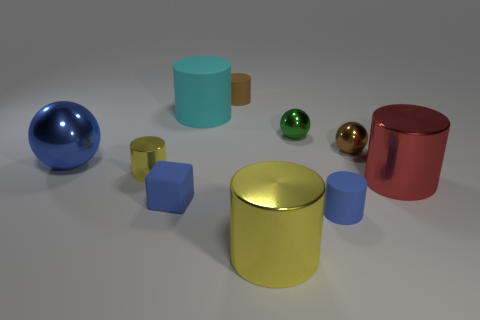Is there any other thing that is the same material as the cyan thing?
Keep it short and to the point. Yes. What number of objects are blue things on the right side of the small yellow metal cylinder or big cyan rubber objects?
Provide a succinct answer. 3. There is a rubber cylinder that is in front of the big blue shiny sphere; how big is it?
Provide a short and direct response. Small. What is the material of the large red cylinder?
Give a very brief answer. Metal. The metal object behind the tiny metal ball that is in front of the green shiny sphere is what shape?
Make the answer very short. Sphere. How many other things are there of the same shape as the small yellow metallic object?
Your response must be concise. 5. There is a large yellow metallic object; are there any cylinders left of it?
Your response must be concise. Yes. What is the color of the block?
Your answer should be compact. Blue. There is a tiny block; is it the same color as the tiny cylinder in front of the small yellow metallic object?
Keep it short and to the point. Yes. Are there any yellow rubber spheres that have the same size as the blue matte cylinder?
Keep it short and to the point. No. 